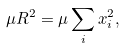<formula> <loc_0><loc_0><loc_500><loc_500>\mu R ^ { 2 } = \mu \sum _ { i } x _ { i } ^ { 2 } ,</formula> 